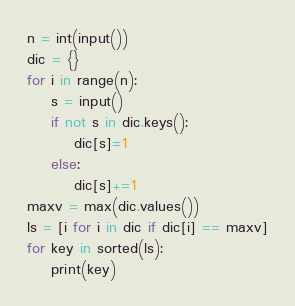<code> <loc_0><loc_0><loc_500><loc_500><_Python_>n = int(input())
dic = {}
for i in range(n):
    s = input()
    if not s in dic.keys():
        dic[s]=1
    else:
        dic[s]+=1
maxv = max(dic.values())
ls = [i for i in dic if dic[i] == maxv]
for key in sorted(ls):
    print(key)</code> 